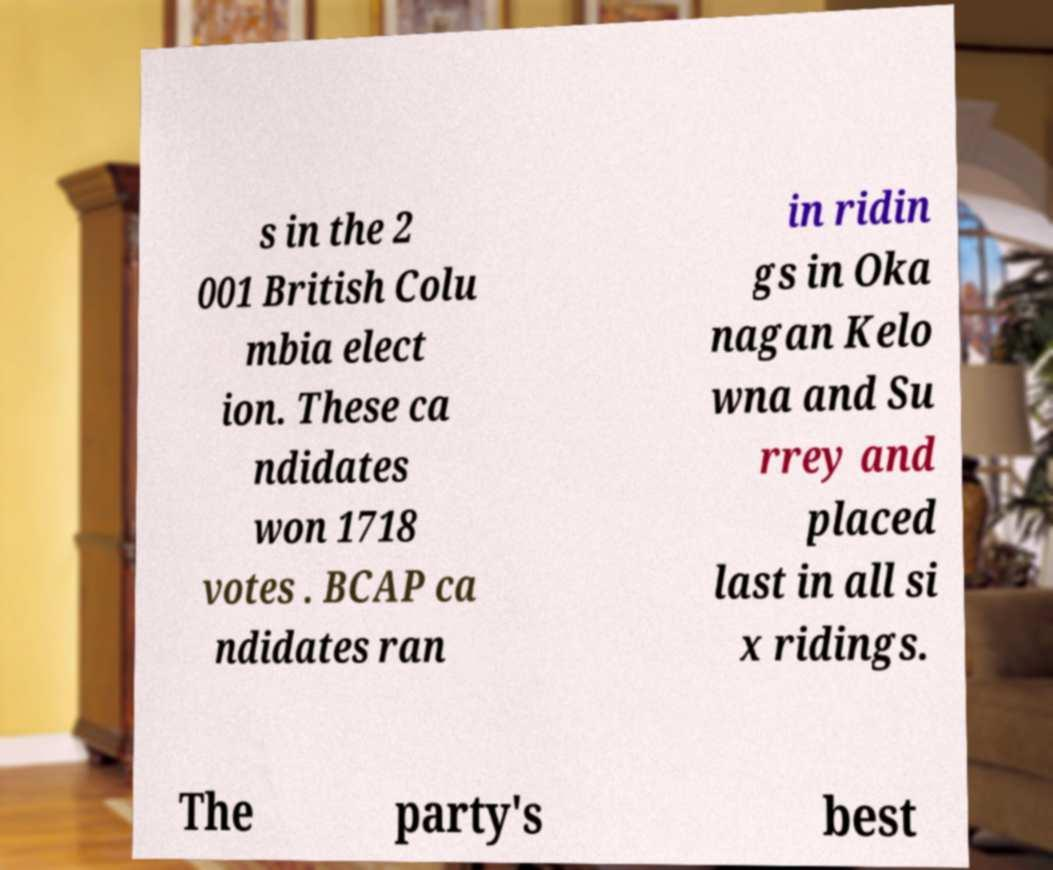For documentation purposes, I need the text within this image transcribed. Could you provide that? s in the 2 001 British Colu mbia elect ion. These ca ndidates won 1718 votes . BCAP ca ndidates ran in ridin gs in Oka nagan Kelo wna and Su rrey and placed last in all si x ridings. The party's best 